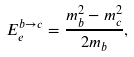Convert formula to latex. <formula><loc_0><loc_0><loc_500><loc_500>E ^ { b \rightarrow c } _ { e } = \frac { m ^ { 2 } _ { b } - m ^ { 2 } _ { c } } { 2 m _ { b } } ,</formula> 